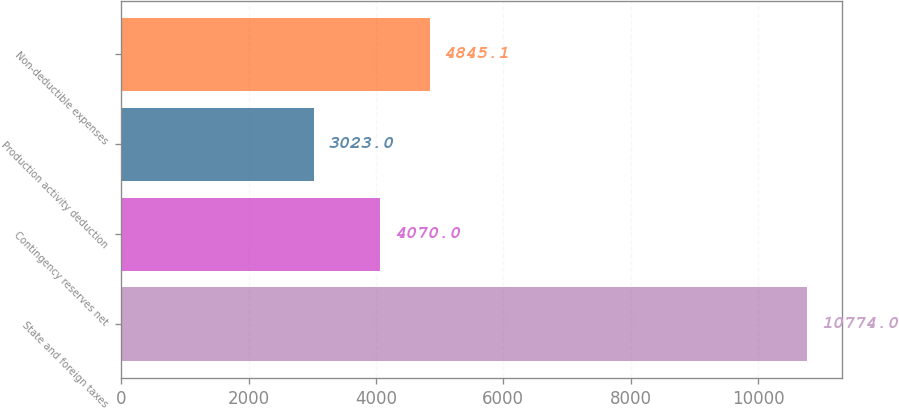Convert chart. <chart><loc_0><loc_0><loc_500><loc_500><bar_chart><fcel>State and foreign taxes<fcel>Contingency reserves net<fcel>Production activity deduction<fcel>Non-deductible expenses<nl><fcel>10774<fcel>4070<fcel>3023<fcel>4845.1<nl></chart> 